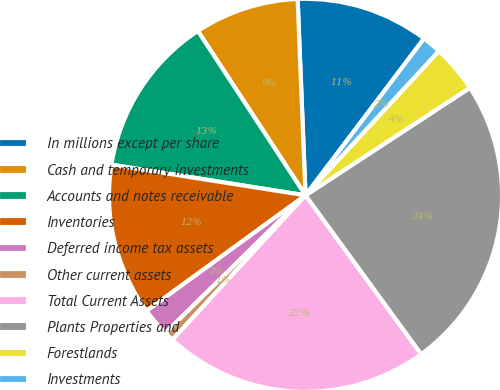Convert chart. <chart><loc_0><loc_0><loc_500><loc_500><pie_chart><fcel>In millions except per share<fcel>Cash and temporary investments<fcel>Accounts and notes receivable<fcel>Inventories<fcel>Deferred income tax assets<fcel>Other current assets<fcel>Total Current Assets<fcel>Plants Properties and<fcel>Forestlands<fcel>Investments<nl><fcel>10.94%<fcel>8.59%<fcel>13.28%<fcel>12.5%<fcel>2.35%<fcel>0.79%<fcel>21.87%<fcel>24.21%<fcel>3.91%<fcel>1.57%<nl></chart> 